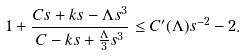Convert formula to latex. <formula><loc_0><loc_0><loc_500><loc_500>1 + \frac { C s + k s - \Lambda s ^ { 3 } } { C - k s + \frac { \Lambda } { 3 } s ^ { 3 } } \leq C ^ { \prime } ( \Lambda ) s ^ { - 2 } - 2 .</formula> 